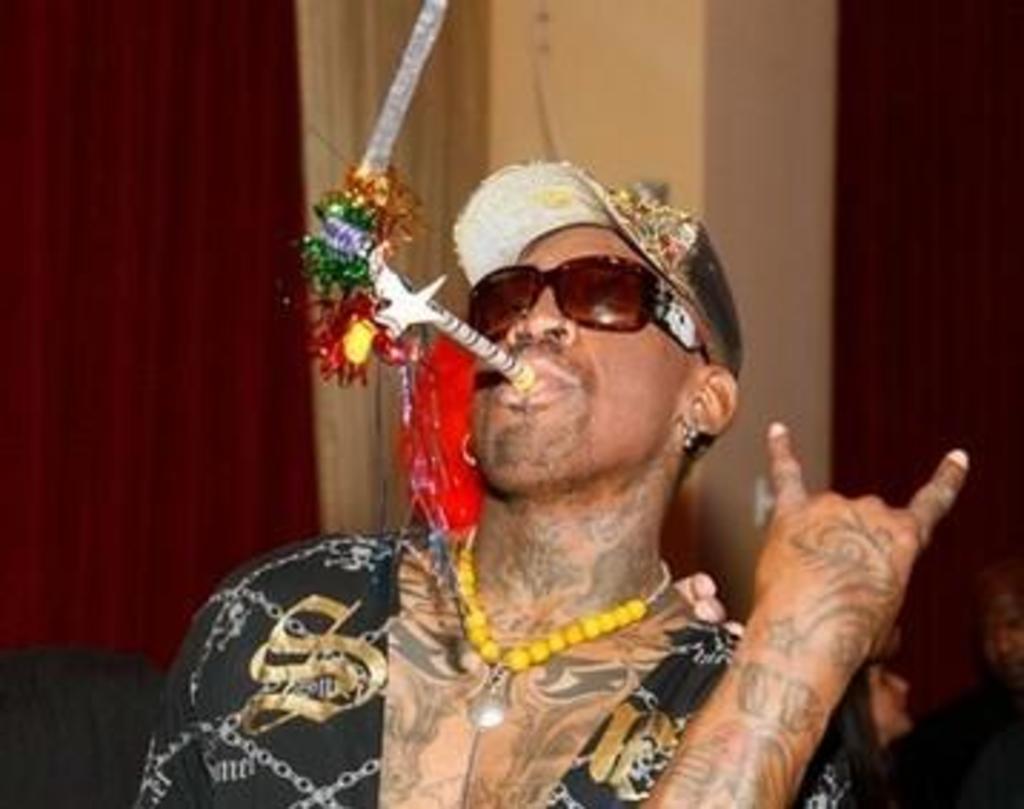Describe this image in one or two sentences. In this picture we can see a person kept a colorful object in his mouth. We can see a goggles and a cap on his head. There are a few people visible on the right side. We can see maroon curtains and it seems like a pillar in the background. 